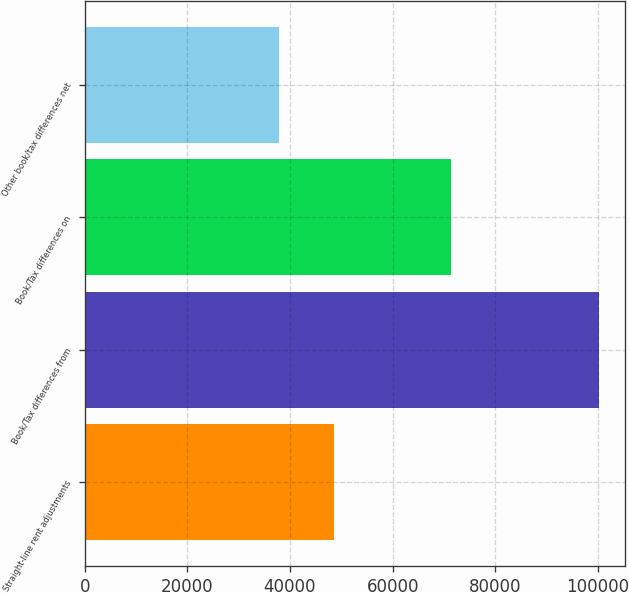<chart> <loc_0><loc_0><loc_500><loc_500><bar_chart><fcel>Straight-line rent adjustments<fcel>Book/Tax differences from<fcel>Book/Tax differences on<fcel>Other book/tax differences net<nl><fcel>48563<fcel>100292<fcel>71456.2<fcel>37860<nl></chart> 